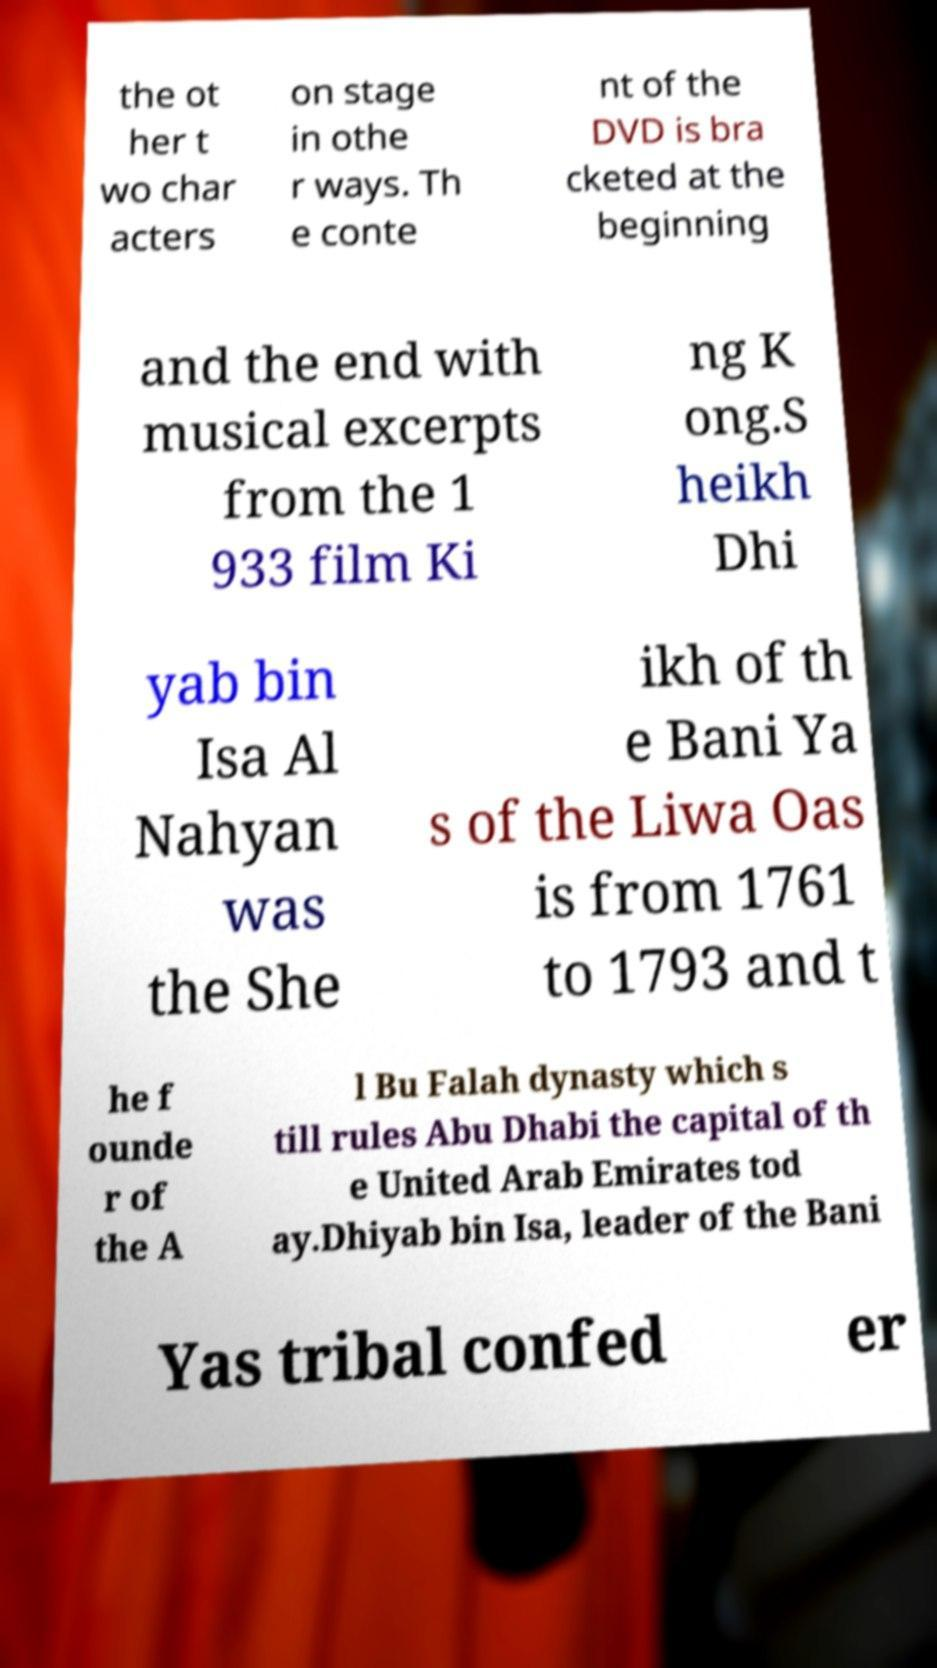Please identify and transcribe the text found in this image. the ot her t wo char acters on stage in othe r ways. Th e conte nt of the DVD is bra cketed at the beginning and the end with musical excerpts from the 1 933 film Ki ng K ong.S heikh Dhi yab bin Isa Al Nahyan was the She ikh of th e Bani Ya s of the Liwa Oas is from 1761 to 1793 and t he f ounde r of the A l Bu Falah dynasty which s till rules Abu Dhabi the capital of th e United Arab Emirates tod ay.Dhiyab bin Isa, leader of the Bani Yas tribal confed er 